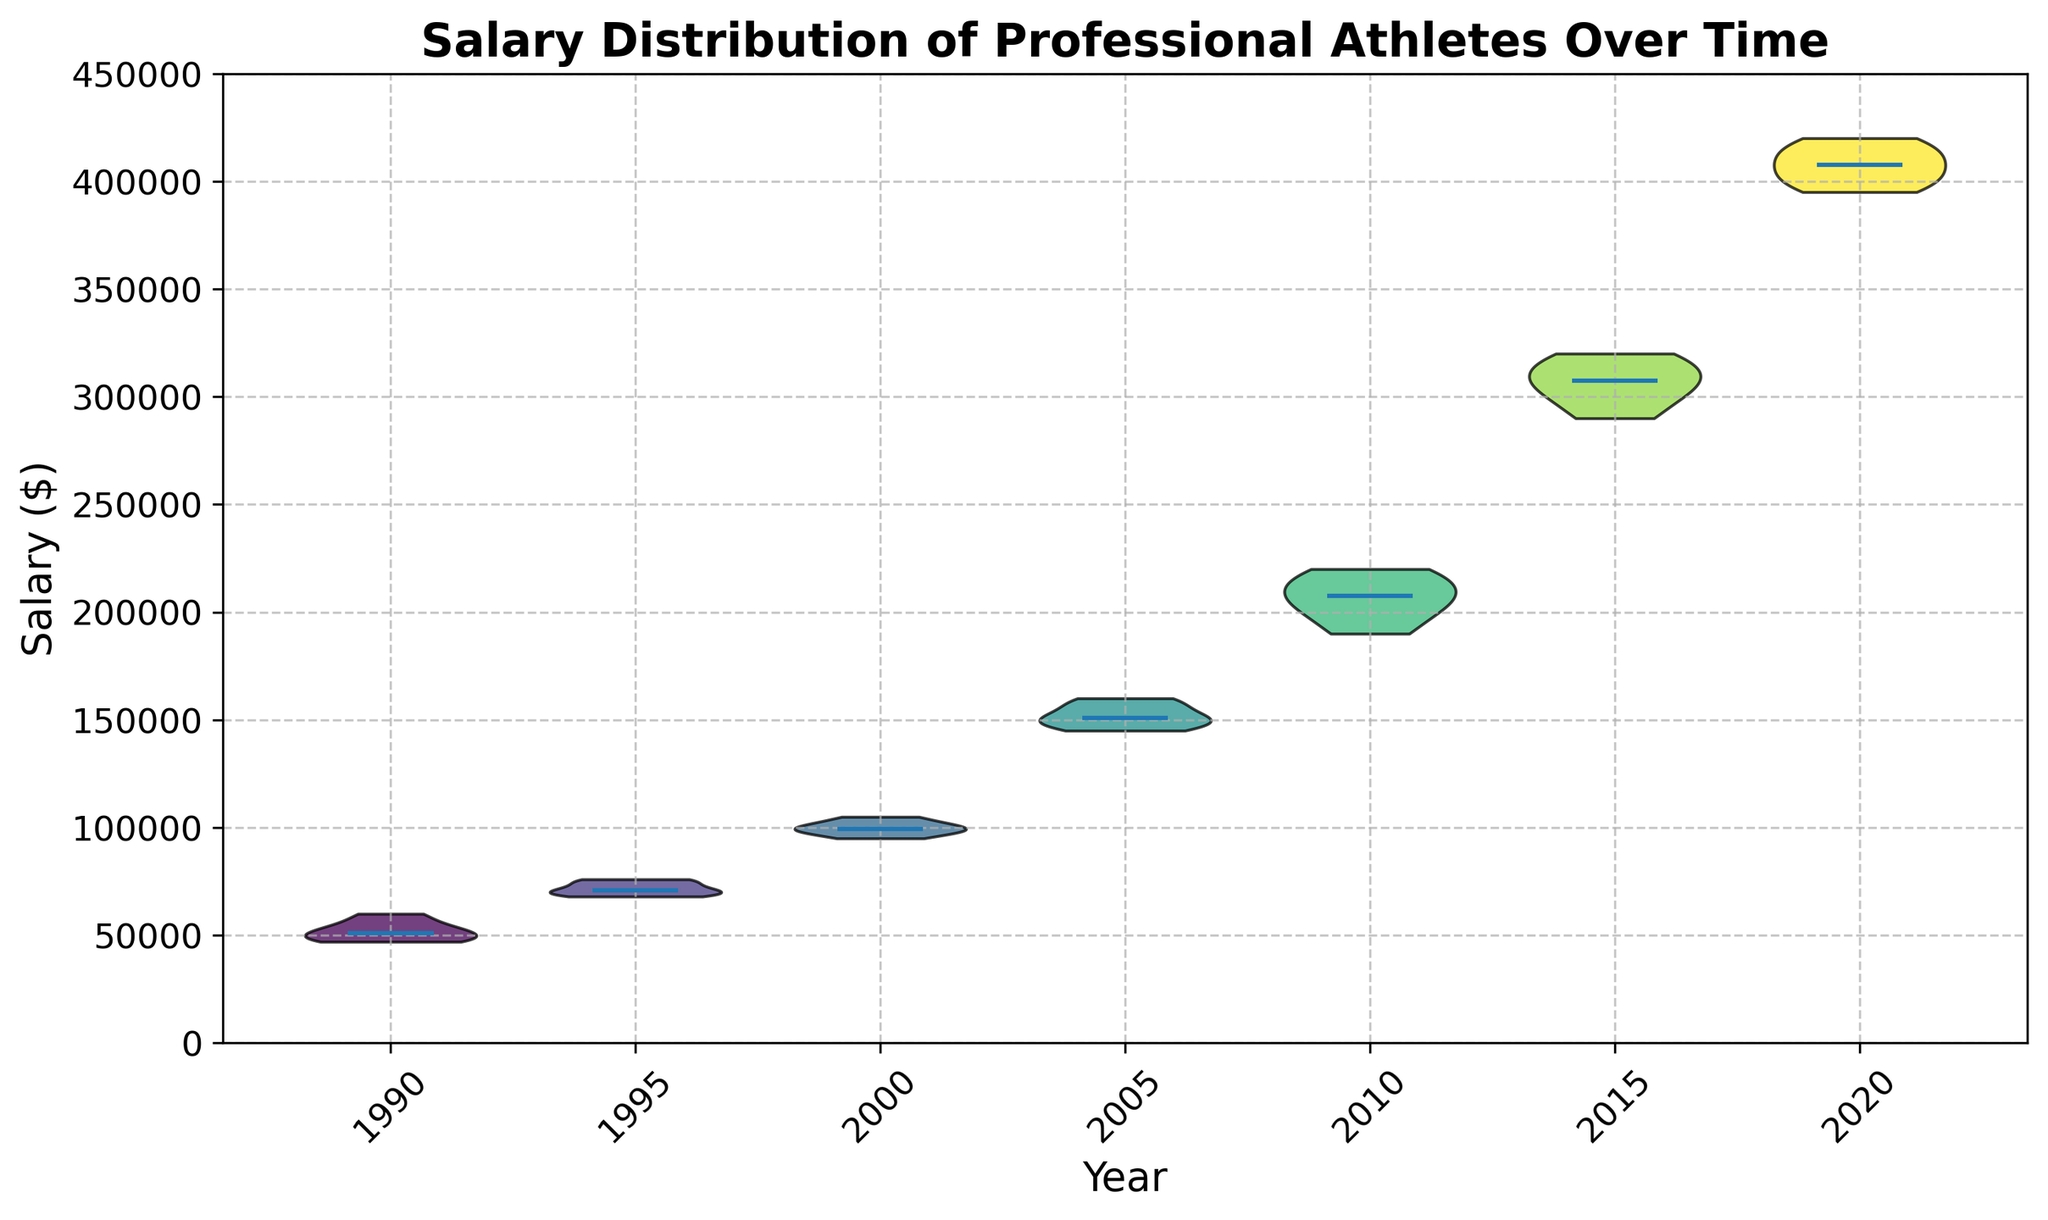Which year has the highest median salary? To determine the highest median salary, observe the violin plot's central line (median) for each year. The 2020 median line is at $410,000.
Answer: 2020 How does the median salary in 2000 compare to 1990? Find the median lines for 1990 and 2000. In 1990, the median is around $50,000, and in 2000, it is around $100,000.
Answer: 2000 is higher What is the difference in median salaries between 2010 and 2005? The median salary in 2005 is approximately $150,000, and in 2010 it is approximately $205,000. The difference is $205,000 - $150,000.
Answer: $55,000 How did the salary distribution change from 1990 to 2015? In 1990, the salaries are tightly clustered around $50,000-$60,000. By 2015, the distribution is wider and the median salary has significantly increased to around $310,000.
Answer: Increased and widened Which year shows the greatest range of salaries? The range is the difference between the highest and lowest data points within each violin. 2020 shows the greatest range, from about $395,000 to $420,000.
Answer: 2020 How does the salary distribution from 2015 compare with that of 2000? In 2000, the salaries are around $95,000-$105,000 with a median of $100,000. In 2015, the range is much broader (around $290,000-$320,000) and the median is higher, at roughly $310,000.
Answer: 2015 is higher and broader What trends can be observed over the entire time span for athlete salaries? The salaries show a consistently increasing trend in their medians from 1990 to 2020, indicating rising pay over the years.
Answer: Increasing trend What is the approximate interquartile range (IQR) for salaries in 2010? The IQR is the range between the 25th and 75th percentiles within the violin. In 2010, visually estimate from the plot that it spans roughly from $195,000 to $215,000, yielding an IQR of 20,000.
Answer: $20,000 